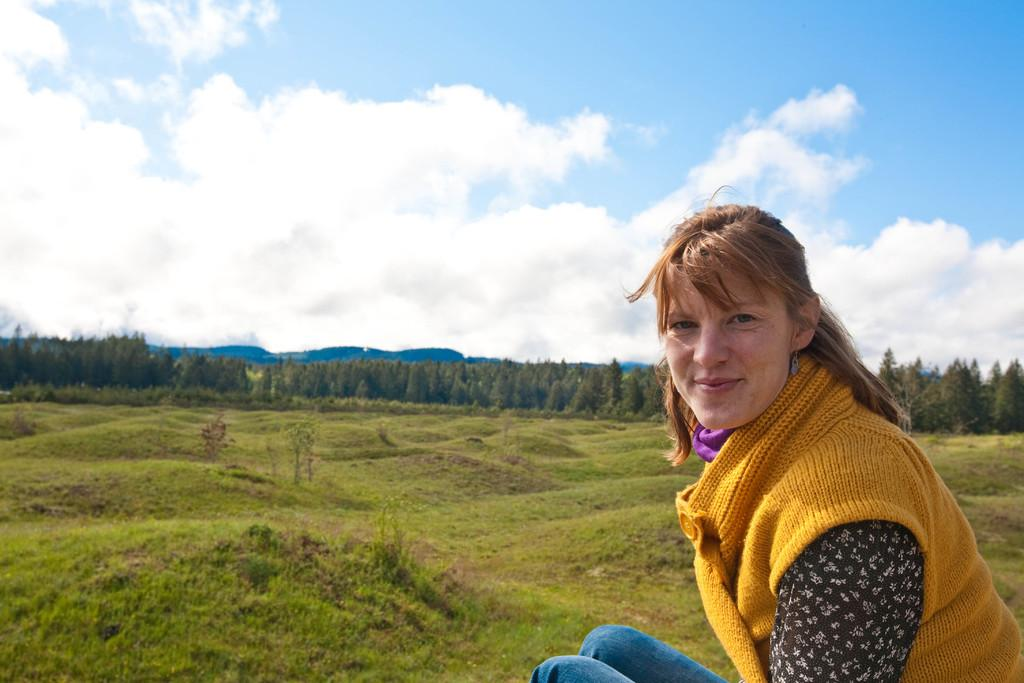Who is the main subject in the image? There is a lady in the image. What is the ground covered with? The ground is covered with grass. Are there any plants visible in the image? Yes, there are a few trees in the image. What can be seen in the sky? The sky is visible with clouds. What type of leather is being used to make the toothbrush in the image? There is no toothbrush present in the image, so it is not possible to determine what type of leather might be used. 